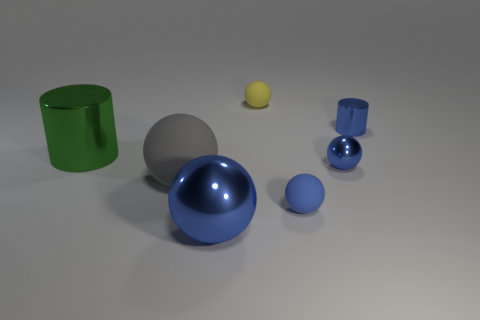Subtract all cyan cubes. How many blue spheres are left? 3 Subtract all gray balls. How many balls are left? 4 Subtract all large metallic balls. How many balls are left? 4 Subtract all red balls. Subtract all red cylinders. How many balls are left? 5 Add 2 tiny blue shiny cylinders. How many objects exist? 9 Subtract all balls. How many objects are left? 2 Subtract all large brown balls. Subtract all cylinders. How many objects are left? 5 Add 4 large gray rubber spheres. How many large gray rubber spheres are left? 5 Add 7 brown cylinders. How many brown cylinders exist? 7 Subtract 0 yellow blocks. How many objects are left? 7 